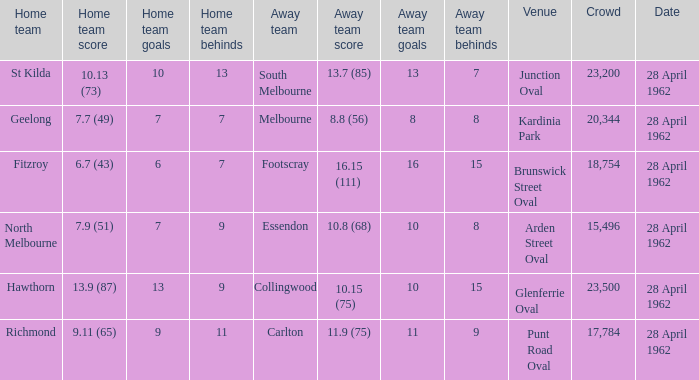What was the crowd size when there was a home team score of 10.13 (73)? 23200.0. 